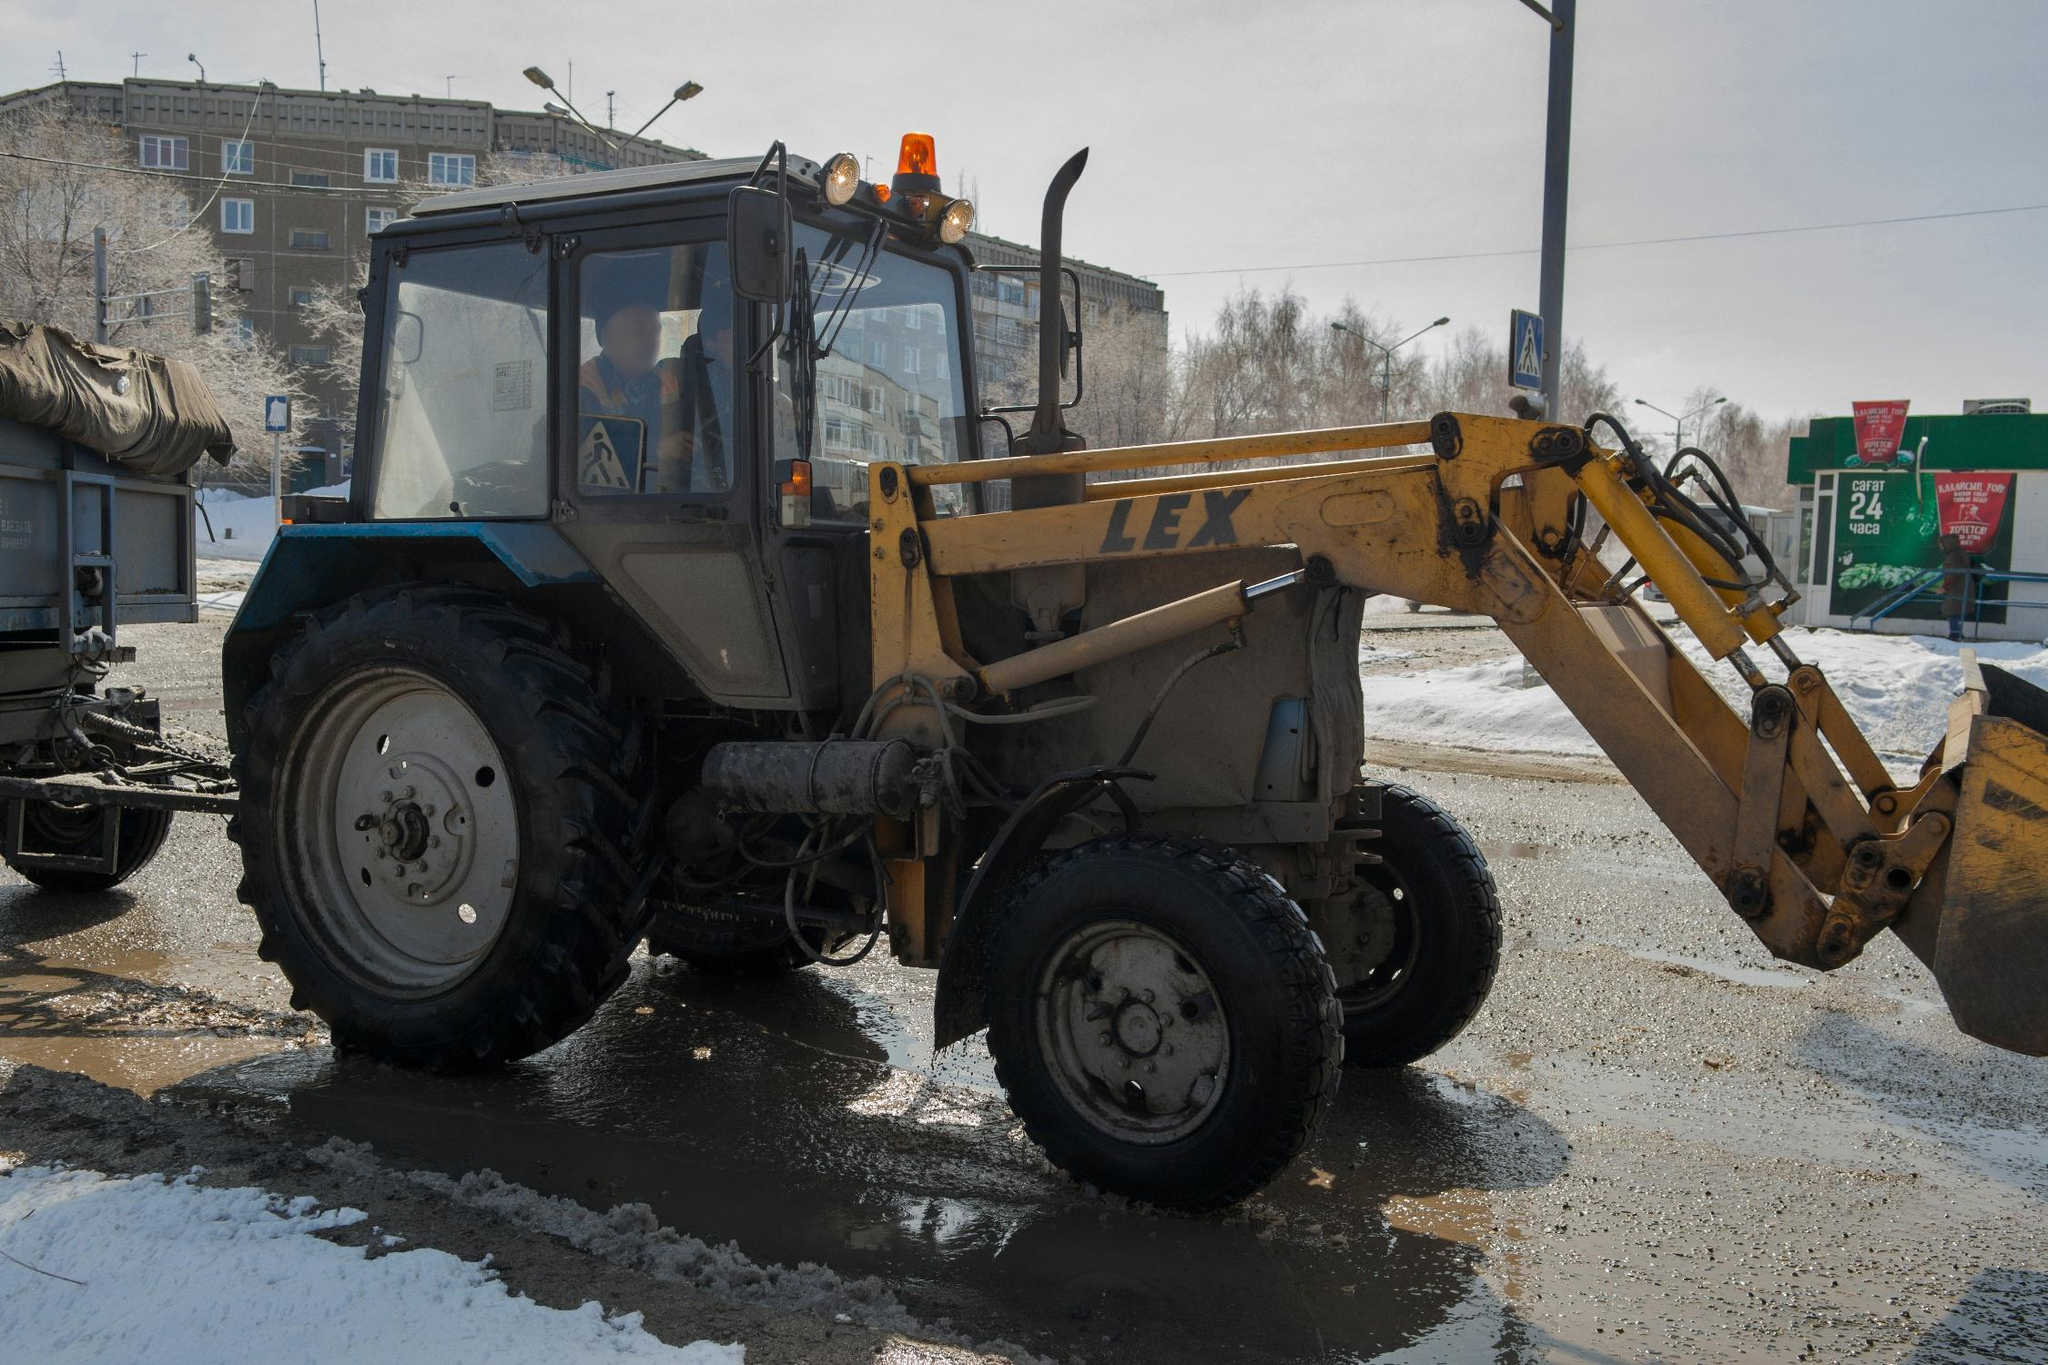What might be the purpose of the tractor in this environment with such harsh conditions? The tractor, equipped with a front loader, is likely used for managing snow removal or transporting road salt to treat icy patches on the road. Its presence in this urban setting during winter suggests it plays an essential role in maintaining road safety and accessibility, helping to minimize disruption caused by snow and ice. 